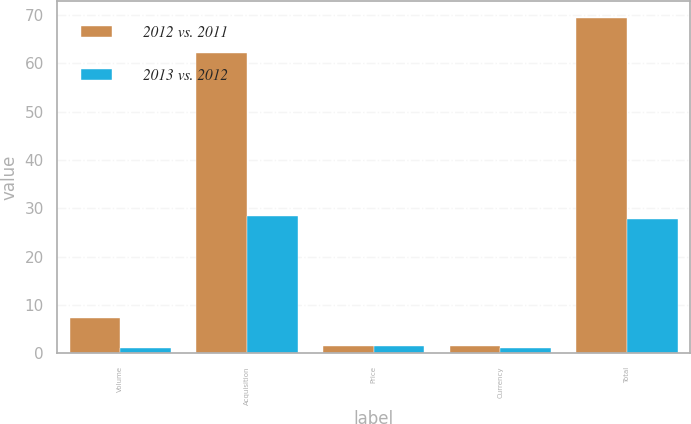Convert chart. <chart><loc_0><loc_0><loc_500><loc_500><stacked_bar_chart><ecel><fcel>Volume<fcel>Acquisition<fcel>Price<fcel>Currency<fcel>Total<nl><fcel>2012 vs. 2011<fcel>7.3<fcel>62.1<fcel>1.4<fcel>1.4<fcel>69.4<nl><fcel>2013 vs. 2012<fcel>1<fcel>28.3<fcel>1.5<fcel>1<fcel>27.8<nl></chart> 